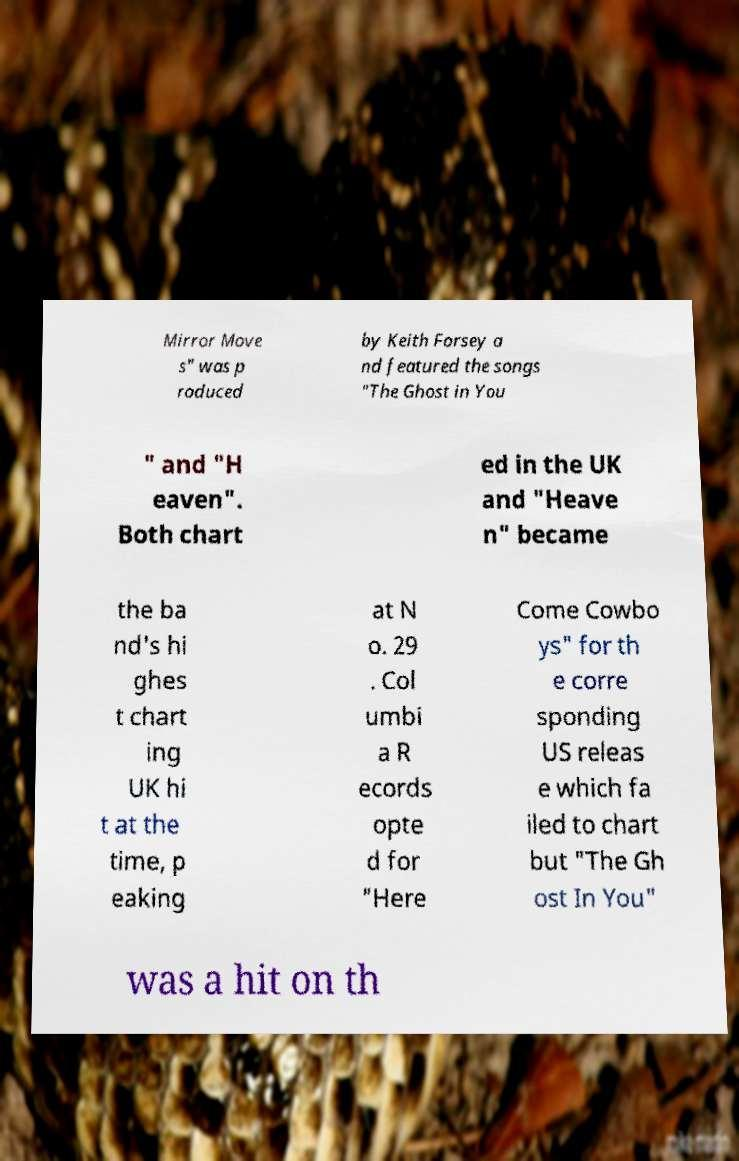Could you assist in decoding the text presented in this image and type it out clearly? Mirror Move s" was p roduced by Keith Forsey a nd featured the songs "The Ghost in You " and "H eaven". Both chart ed in the UK and "Heave n" became the ba nd's hi ghes t chart ing UK hi t at the time, p eaking at N o. 29 . Col umbi a R ecords opte d for "Here Come Cowbo ys" for th e corre sponding US releas e which fa iled to chart but "The Gh ost In You" was a hit on th 